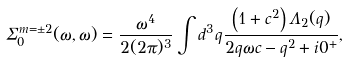<formula> <loc_0><loc_0><loc_500><loc_500>\Sigma _ { 0 } ^ { m = \pm 2 } ( \omega , \omega ) = \frac { \omega ^ { 4 } } { 2 ( 2 \pi ) ^ { 3 } } \int d ^ { 3 } { q } \frac { \left ( 1 + c ^ { 2 } \right ) \Lambda _ { 2 } ( q ) } { 2 q \omega c - q ^ { 2 } + i 0 ^ { + } } ,</formula> 